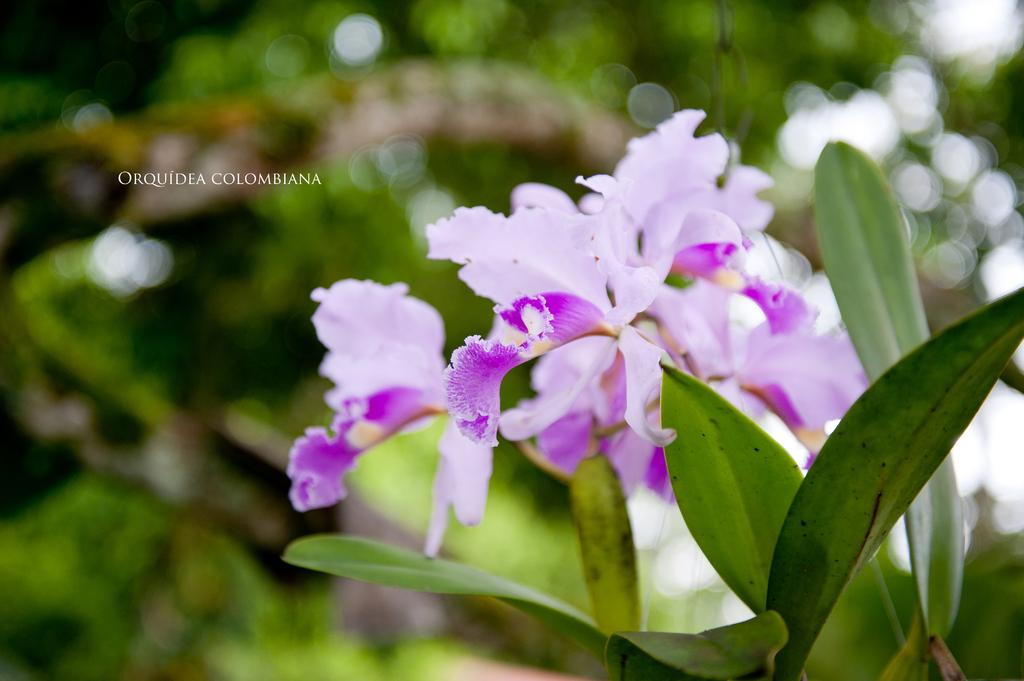What type of plant is visible in the image? There are flowers on a plant in the image. Can you describe the flowers on the plant? Unfortunately, the facts provided do not give any details about the flowers on the plant. What might be the purpose of the plant in the image? The purpose of the plant in the image is not specified, but it could be for decoration or for its flowers. What type of frame is used to show the expansion of the plant in the image? There is no mention of a frame or expansion in the image, as it only features a plant with flowers. 